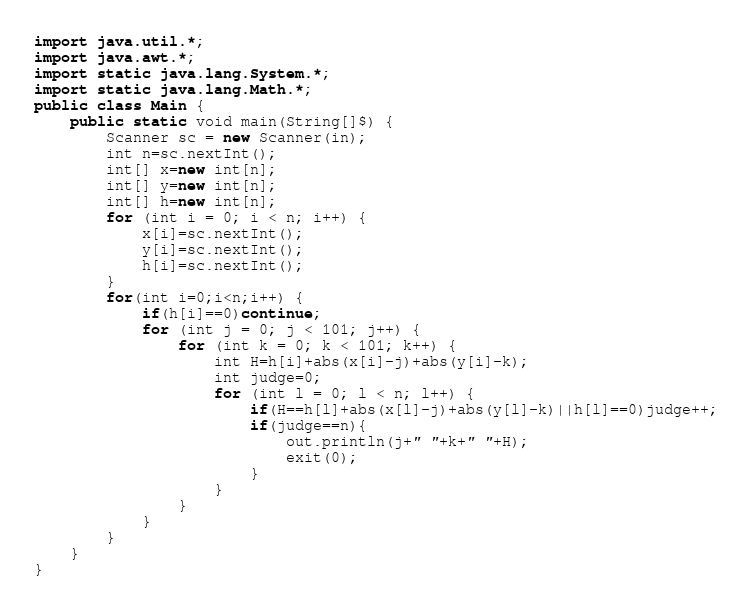Convert code to text. <code><loc_0><loc_0><loc_500><loc_500><_Java_>import java.util.*;
import java.awt.*;
import static java.lang.System.*;
import static java.lang.Math.*;
public class Main {
    public static void main(String[]$) {
        Scanner sc = new Scanner(in);
        int n=sc.nextInt();
        int[] x=new int[n];
        int[] y=new int[n];
        int[] h=new int[n];
        for (int i = 0; i < n; i++) {
            x[i]=sc.nextInt();
            y[i]=sc.nextInt();
            h[i]=sc.nextInt();
        }
        for(int i=0;i<n;i++) {
            if(h[i]==0)continue;
            for (int j = 0; j < 101; j++) {
                for (int k = 0; k < 101; k++) {
                    int H=h[i]+abs(x[i]-j)+abs(y[i]-k);
                    int judge=0;
                    for (int l = 0; l < n; l++) {
                        if(H==h[l]+abs(x[l]-j)+abs(y[l]-k)||h[l]==0)judge++;
                        if(judge==n){
                            out.println(j+" "+k+" "+H);
                            exit(0);
                        }
                    }
                }
            }
        }
    }
}</code> 